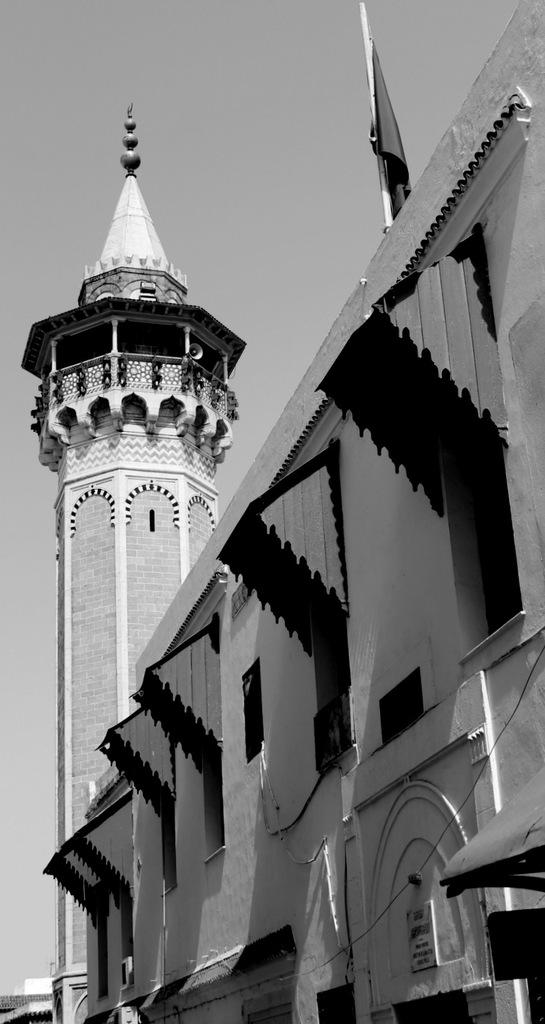What type of structure is visible in the image? There is a building in the image. Are there any specific features of the building that can be seen? Yes, there are windows and a tower visible in the image. What is attached to the tower in the image? There is a flag attached to the tower in the image. What is the color scheme of the image? The image is in black and white. How many minutes does it take for the field to appear in the image? There is no field present in the image, so it is not possible to determine how long it would take for one to appear. 